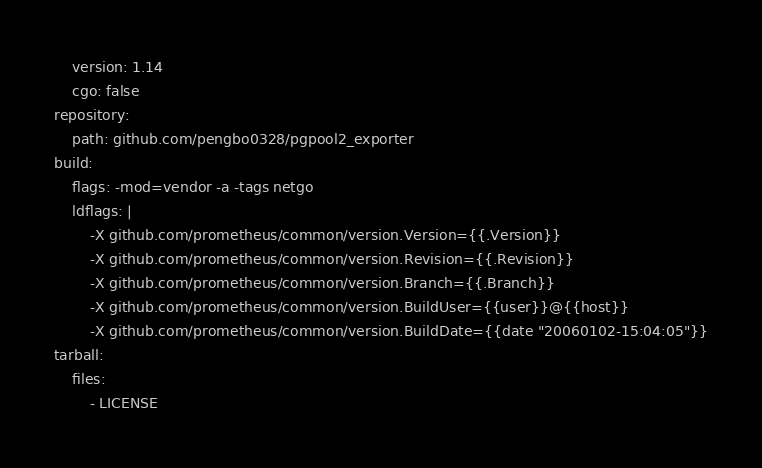<code> <loc_0><loc_0><loc_500><loc_500><_YAML_>    version: 1.14
    cgo: false
repository:
    path: github.com/pengbo0328/pgpool2_exporter
build:
    flags: -mod=vendor -a -tags netgo
    ldflags: |
        -X github.com/prometheus/common/version.Version={{.Version}}
        -X github.com/prometheus/common/version.Revision={{.Revision}}
        -X github.com/prometheus/common/version.Branch={{.Branch}}
        -X github.com/prometheus/common/version.BuildUser={{user}}@{{host}}
        -X github.com/prometheus/common/version.BuildDate={{date "20060102-15:04:05"}}
tarball:
    files:
        - LICENSE
</code> 